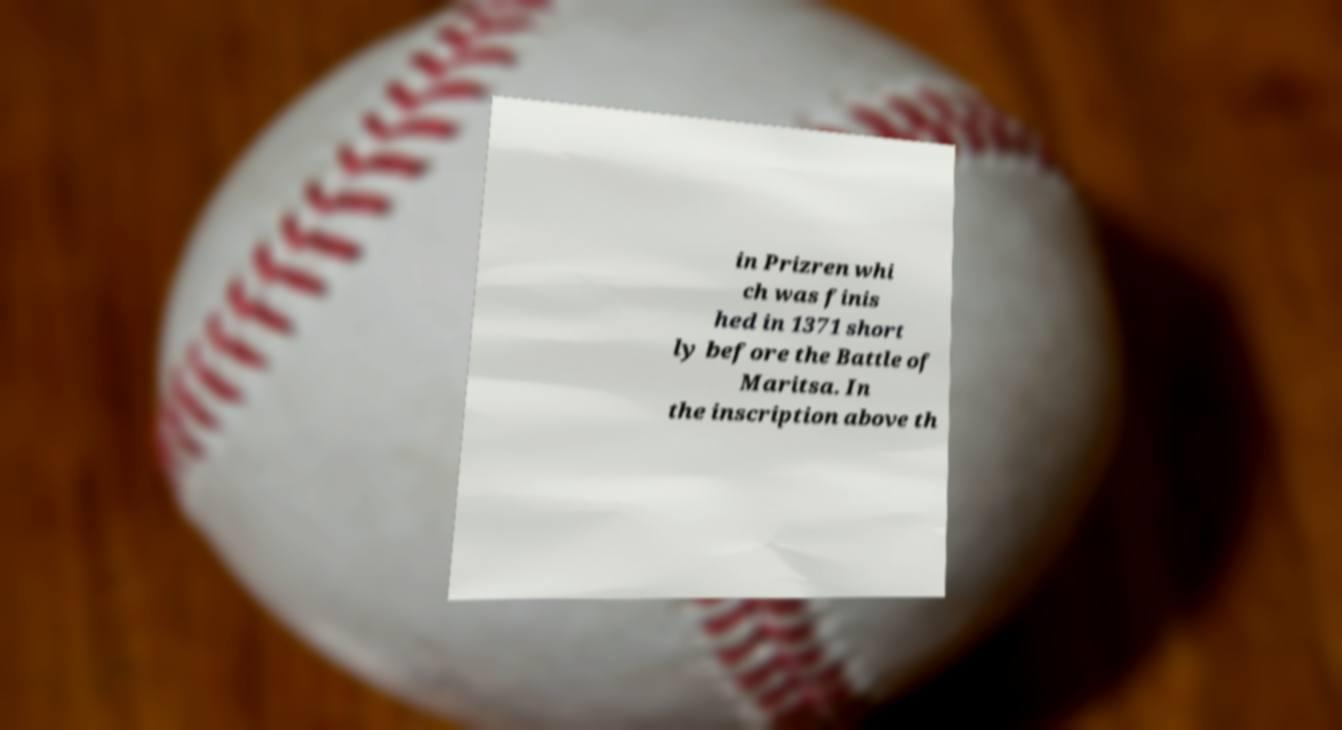I need the written content from this picture converted into text. Can you do that? in Prizren whi ch was finis hed in 1371 short ly before the Battle of Maritsa. In the inscription above th 